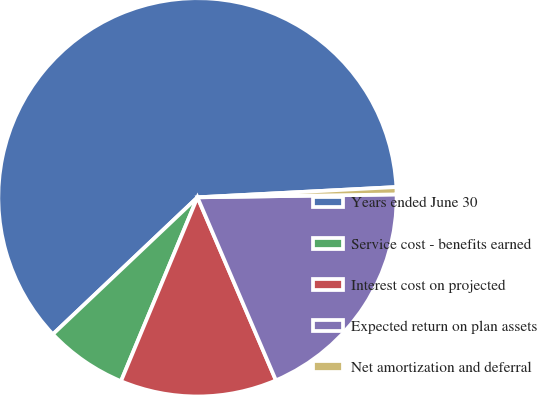Convert chart to OTSL. <chart><loc_0><loc_0><loc_500><loc_500><pie_chart><fcel>Years ended June 30<fcel>Service cost - benefits earned<fcel>Interest cost on projected<fcel>Expected return on plan assets<fcel>Net amortization and deferral<nl><fcel>61.25%<fcel>6.66%<fcel>12.72%<fcel>18.79%<fcel>0.59%<nl></chart> 